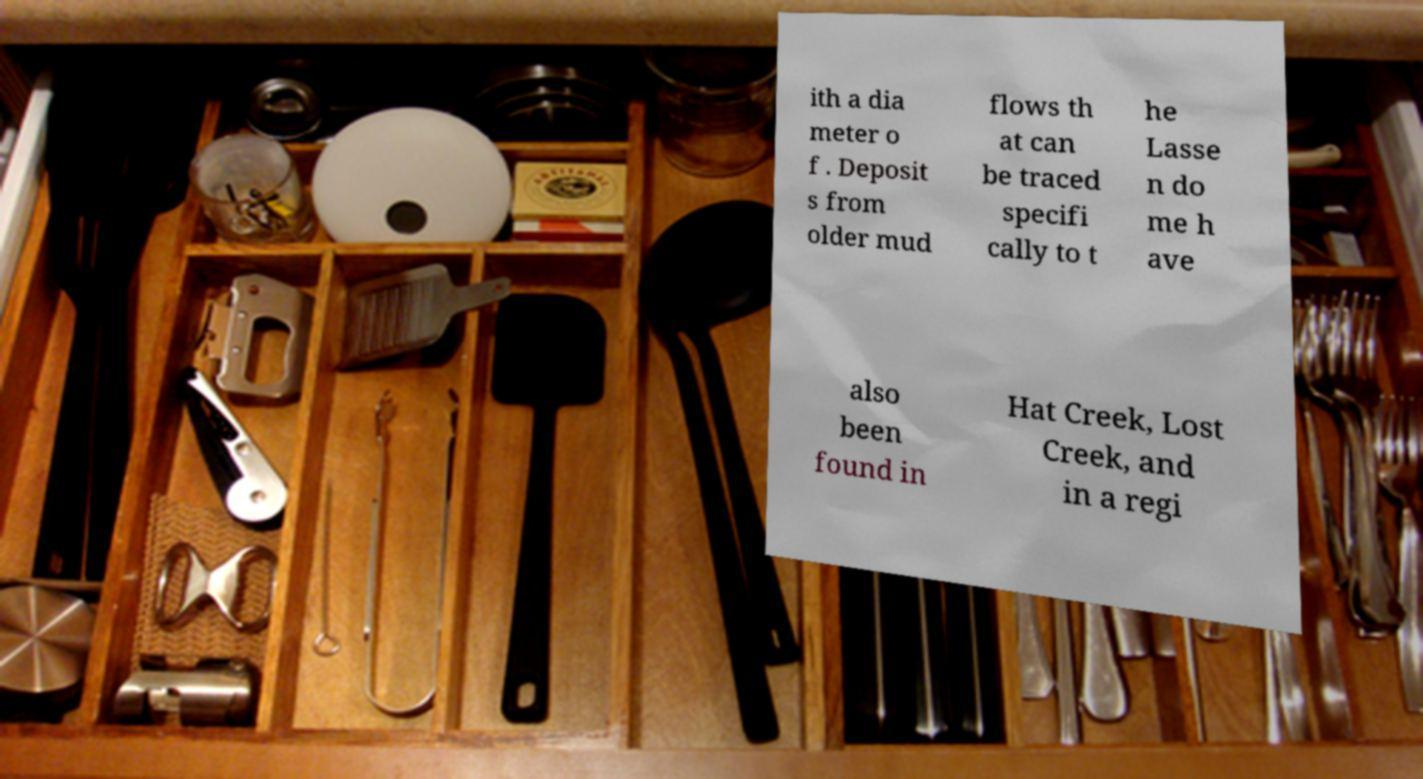What messages or text are displayed in this image? I need them in a readable, typed format. ith a dia meter o f . Deposit s from older mud flows th at can be traced specifi cally to t he Lasse n do me h ave also been found in Hat Creek, Lost Creek, and in a regi 